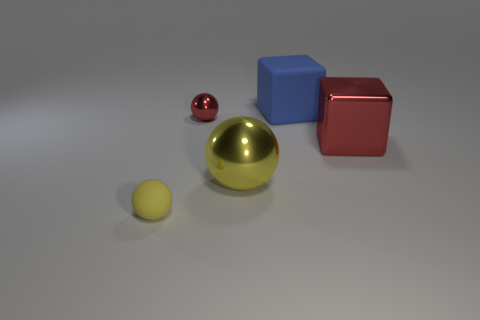Subtract all red metal spheres. How many spheres are left? 2 Add 2 yellow rubber blocks. How many objects exist? 7 Subtract all yellow spheres. How many spheres are left? 1 Subtract 1 cubes. How many cubes are left? 1 Add 5 blue things. How many blue things are left? 6 Add 4 gray matte balls. How many gray matte balls exist? 4 Subtract 0 gray cubes. How many objects are left? 5 Subtract all blocks. How many objects are left? 3 Subtract all brown cubes. Subtract all red spheres. How many cubes are left? 2 Subtract all purple cubes. How many green spheres are left? 0 